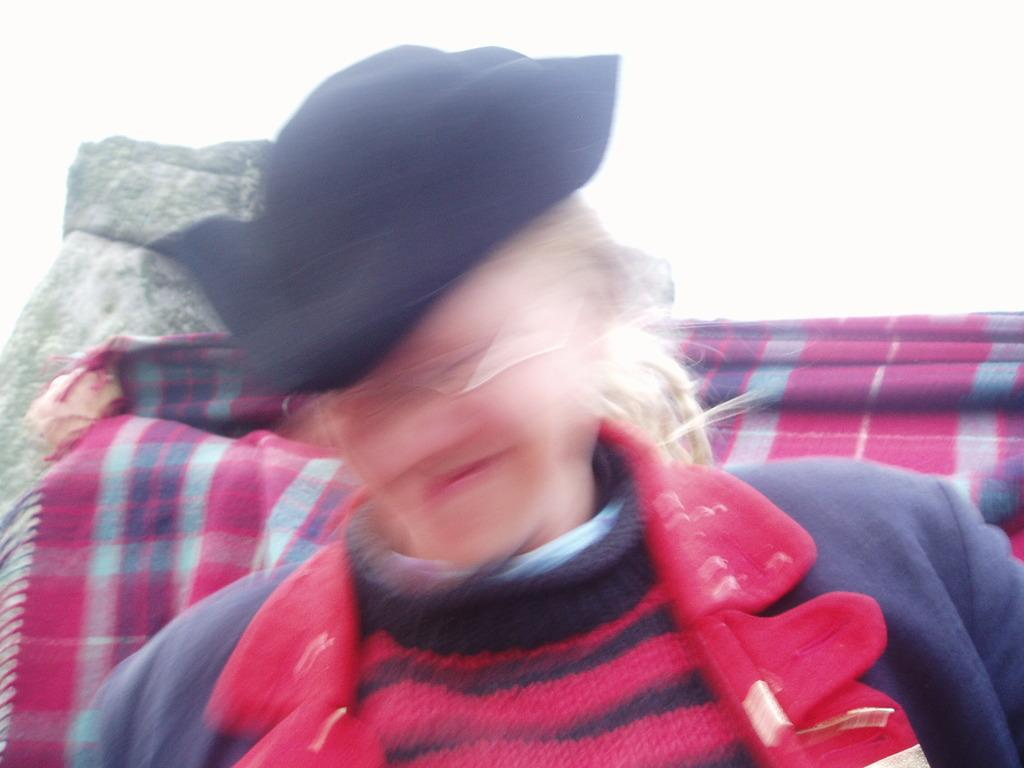What is the main subject of the image? There is a person in the image. Can you describe the blanket in the image? There is a colorful blanket on a stone in the image. How many giraffes can be seen near the tent in the image? There is no tent or giraffe present in the image. 